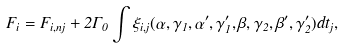Convert formula to latex. <formula><loc_0><loc_0><loc_500><loc_500>F _ { i } = F _ { i , n j } + 2 \Gamma _ { 0 } \int \xi _ { i , j } ( \alpha , \gamma _ { 1 } , \alpha ^ { \prime } , \gamma ^ { \prime } _ { 1 } , \beta , \gamma _ { 2 } , \beta ^ { \prime } , \gamma ^ { \prime } _ { 2 } ) d t _ { j } ,</formula> 